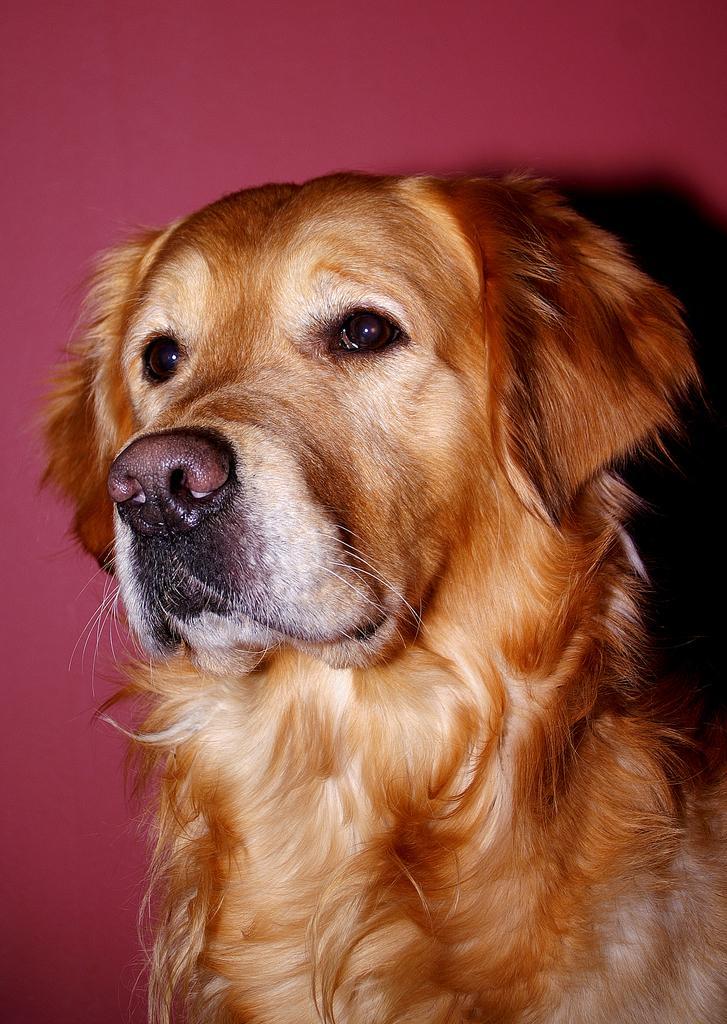How would you summarize this image in a sentence or two? The picture consists of a dog. In the background it is wall painted pink. 